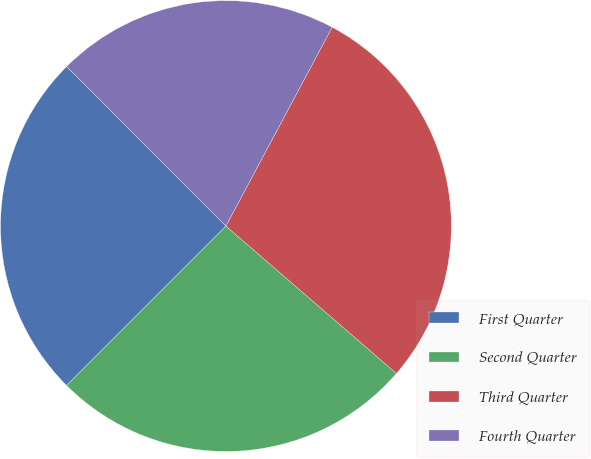<chart> <loc_0><loc_0><loc_500><loc_500><pie_chart><fcel>First Quarter<fcel>Second Quarter<fcel>Third Quarter<fcel>Fourth Quarter<nl><fcel>25.01%<fcel>26.15%<fcel>28.54%<fcel>20.3%<nl></chart> 